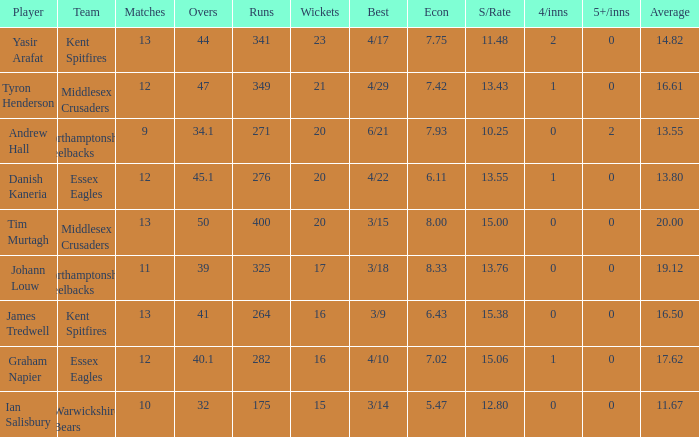For the best figure of 4/22, how many wickets were captured at most? 20.0. 